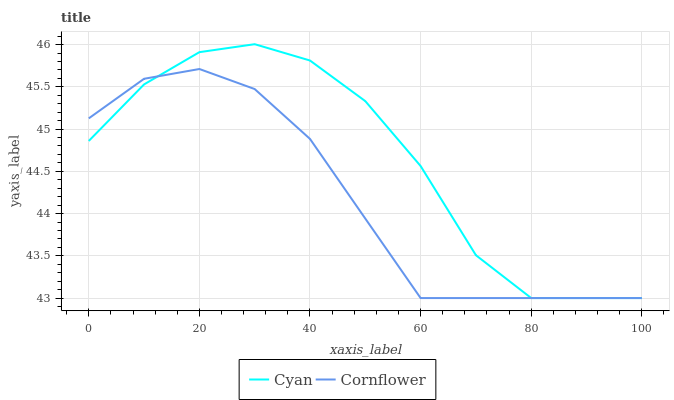Does Cornflower have the minimum area under the curve?
Answer yes or no. Yes. Does Cyan have the maximum area under the curve?
Answer yes or no. Yes. Does Cornflower have the maximum area under the curve?
Answer yes or no. No. Is Cornflower the smoothest?
Answer yes or no. Yes. Is Cyan the roughest?
Answer yes or no. Yes. Is Cornflower the roughest?
Answer yes or no. No. Does Cyan have the highest value?
Answer yes or no. Yes. Does Cornflower have the highest value?
Answer yes or no. No. Does Cyan intersect Cornflower?
Answer yes or no. Yes. Is Cyan less than Cornflower?
Answer yes or no. No. Is Cyan greater than Cornflower?
Answer yes or no. No. 